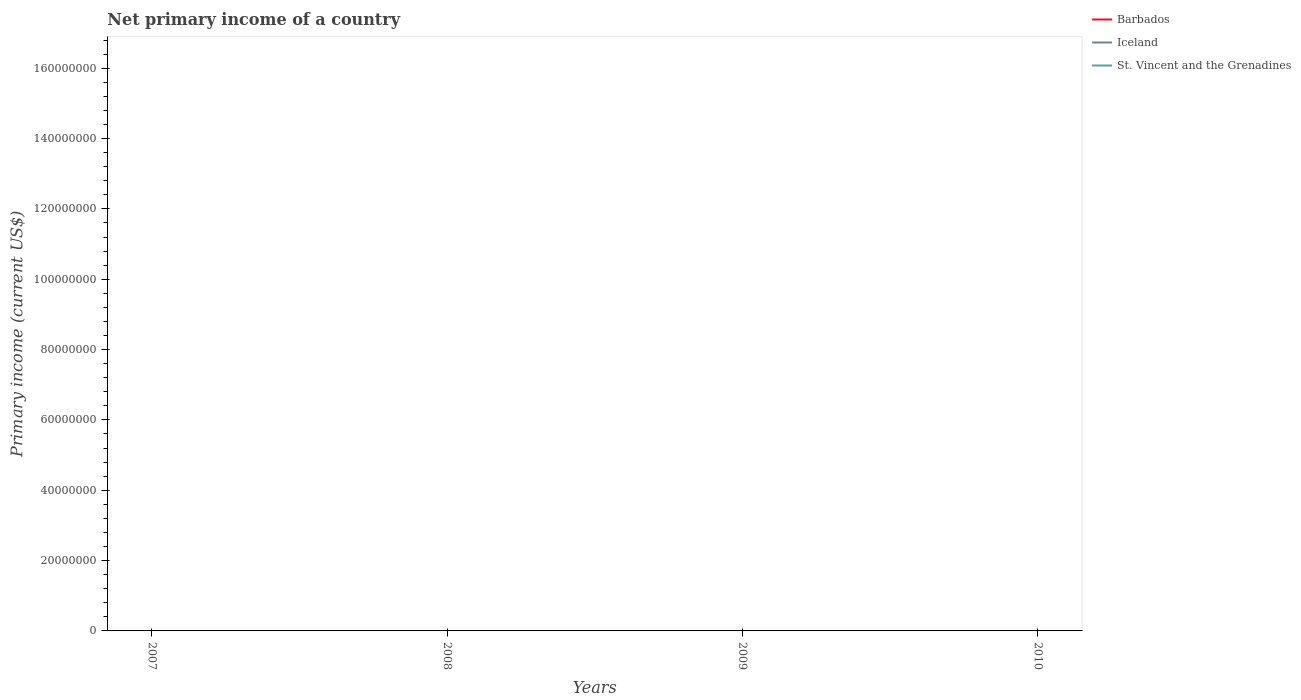Does the line corresponding to St. Vincent and the Grenadines intersect with the line corresponding to Iceland?
Make the answer very short. No. Is the number of lines equal to the number of legend labels?
Provide a short and direct response. No. Are the values on the major ticks of Y-axis written in scientific E-notation?
Offer a terse response. No. How are the legend labels stacked?
Offer a terse response. Vertical. What is the title of the graph?
Provide a short and direct response. Net primary income of a country. What is the label or title of the X-axis?
Offer a very short reply. Years. What is the label or title of the Y-axis?
Keep it short and to the point. Primary income (current US$). What is the Primary income (current US$) of Barbados in 2007?
Provide a short and direct response. 0. What is the Primary income (current US$) in St. Vincent and the Grenadines in 2007?
Your response must be concise. 0. What is the Primary income (current US$) in Barbados in 2008?
Ensure brevity in your answer.  0. What is the Primary income (current US$) in St. Vincent and the Grenadines in 2008?
Your answer should be very brief. 0. What is the Primary income (current US$) of Barbados in 2010?
Give a very brief answer. 0. What is the Primary income (current US$) in Iceland in 2010?
Ensure brevity in your answer.  0. What is the total Primary income (current US$) of Barbados in the graph?
Offer a very short reply. 0. What is the total Primary income (current US$) in Iceland in the graph?
Provide a succinct answer. 0. What is the total Primary income (current US$) in St. Vincent and the Grenadines in the graph?
Keep it short and to the point. 0. What is the average Primary income (current US$) of Barbados per year?
Give a very brief answer. 0. What is the average Primary income (current US$) in Iceland per year?
Ensure brevity in your answer.  0. What is the average Primary income (current US$) of St. Vincent and the Grenadines per year?
Make the answer very short. 0. 